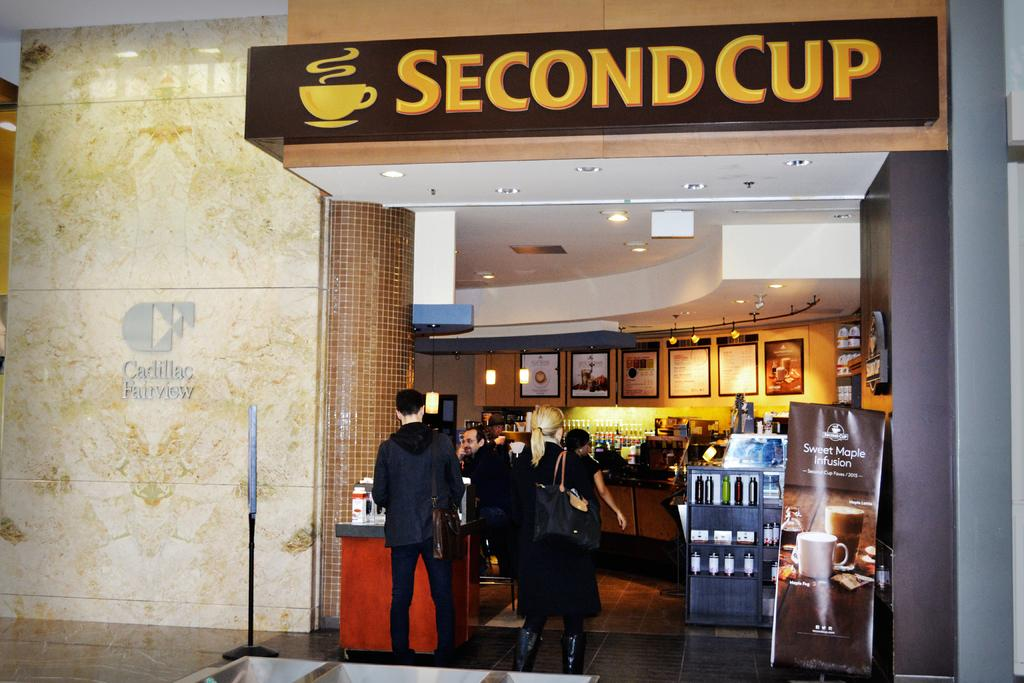<image>
Offer a succinct explanation of the picture presented. Outside of a coffee shop with customers named, "Second Cup." 